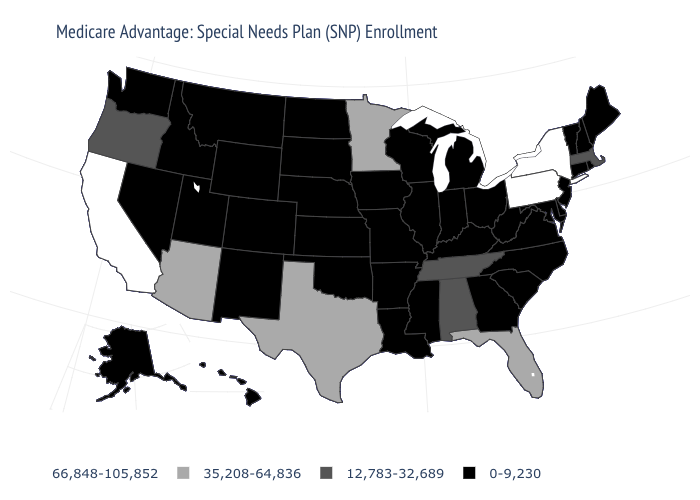What is the value of Ohio?
Concise answer only. 0-9,230. Name the states that have a value in the range 35,208-64,836?
Answer briefly. Arizona, Florida, Minnesota, Texas. Among the states that border Rhode Island , which have the highest value?
Give a very brief answer. Massachusetts. Is the legend a continuous bar?
Be succinct. No. Is the legend a continuous bar?
Keep it brief. No. Does Minnesota have the highest value in the MidWest?
Keep it brief. Yes. Among the states that border Oklahoma , which have the lowest value?
Quick response, please. Arkansas, Colorado, Kansas, Missouri, New Mexico. Is the legend a continuous bar?
Write a very short answer. No. What is the value of Iowa?
Answer briefly. 0-9,230. Which states have the highest value in the USA?
Be succinct. California, New York, Pennsylvania. What is the value of Illinois?
Quick response, please. 0-9,230. What is the value of Ohio?
Short answer required. 0-9,230. Among the states that border Montana , which have the lowest value?
Write a very short answer. Idaho, North Dakota, South Dakota, Wyoming. Name the states that have a value in the range 66,848-105,852?
Keep it brief. California, New York, Pennsylvania. What is the value of Michigan?
Keep it brief. 0-9,230. 